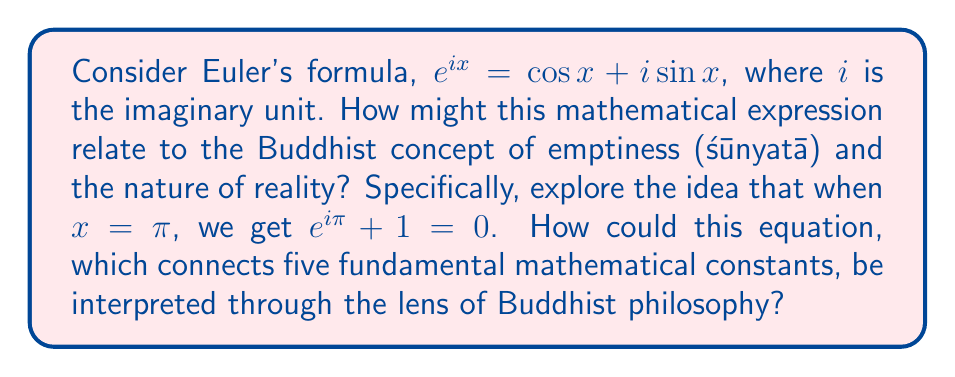Help me with this question. To understand the connection between Euler's formula and the Buddhist concept of emptiness, we need to examine both the mathematical and philosophical aspects:

1. Euler's formula: $e^{ix} = \cos x + i \sin x$

This formula connects complex exponentials to trigonometric functions. When we set $x = \pi$, we get:

$e^{i\pi} = \cos \pi + i \sin \pi = -1 + 0i = -1$

Rearranging, we get the famous equation: $e^{i\pi} + 1 = 0$

2. Buddhist concept of emptiness (śūnyatā):

In Buddhism, emptiness refers to the lack of inherent existence in all phenomena. It suggests that nothing exists independently or permanently, but rather in relation to other things.

3. Interpretation:

a) Unity of opposites: The equation $e^{i\pi} + 1 = 0$ brings together seemingly disparate mathematical concepts (e, i, π, 1, and 0) into a single, elegant relationship. This mirrors the Buddhist idea that all phenomena are interconnected and lack independent existence.

b) Transcendence of duality: The equation combines real and imaginary numbers, potentially symbolizing the transcendence of conventional dualistic thinking in Buddhism.

c) Form is emptiness, emptiness is form: The Heart Sutra states, "Form is emptiness, emptiness is form." Similarly, the equation shows how complex mathematical entities (form) can result in zero (emptiness), and how zero arises from the interaction of these entities.

d) Middle way: The equation balances positive and negative, real and imaginary, resulting in zero. This could be seen as a mathematical expression of the Buddhist middle way between extremes.

e) Interdependence: Each component of the equation is essential for the whole, reflecting the Buddhist concept of dependent origination (pratītyasamutpāda).

f) Non-duality of existence and non-existence: The equation equates something ($e^{i\pi} + 1$) with nothing (0), potentially illustrating the Buddhist view that existence and non-existence are not absolute opposites but interdependent concepts.
Answer: The connection between Euler's formula and the Buddhist concept of emptiness lies in their shared themes of unity, interconnectedness, and the transcendence of apparent opposites. Euler's equation $e^{i\pi} + 1 = 0$ can be interpreted as a mathematical expression of śūnyatā, illustrating the interdependence of seemingly disparate elements, the unity of form and emptiness, and the non-dual nature of existence and non-existence. 